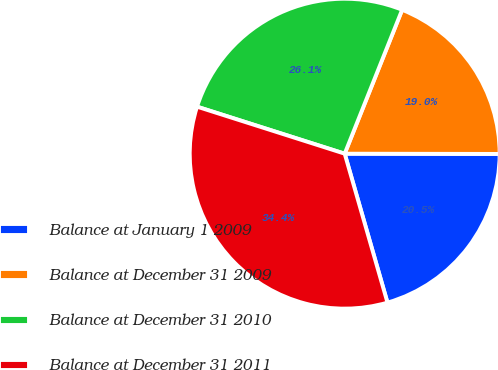Convert chart. <chart><loc_0><loc_0><loc_500><loc_500><pie_chart><fcel>Balance at January 1 2009<fcel>Balance at December 31 2009<fcel>Balance at December 31 2010<fcel>Balance at December 31 2011<nl><fcel>20.52%<fcel>18.98%<fcel>26.14%<fcel>34.36%<nl></chart> 